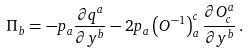Convert formula to latex. <formula><loc_0><loc_0><loc_500><loc_500>\Pi _ { b } = - p _ { a } \frac { \partial q ^ { a } } { \partial y ^ { b } } - 2 p _ { a } \left ( O ^ { - 1 } \right ) ^ { c } _ { a } \frac { \partial O ^ { a } _ { c } } { \partial y ^ { b } } \, .</formula> 